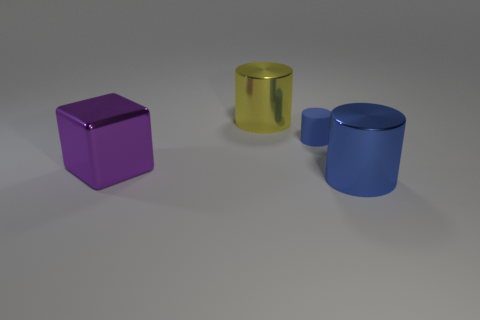Subtract all brown blocks. Subtract all red spheres. How many blocks are left? 1 Add 4 big yellow metallic cylinders. How many objects exist? 8 Subtract all cylinders. How many objects are left? 1 Subtract all big metallic cylinders. Subtract all rubber cylinders. How many objects are left? 1 Add 4 purple things. How many purple things are left? 5 Add 2 big yellow objects. How many big yellow objects exist? 3 Subtract 0 cyan cylinders. How many objects are left? 4 